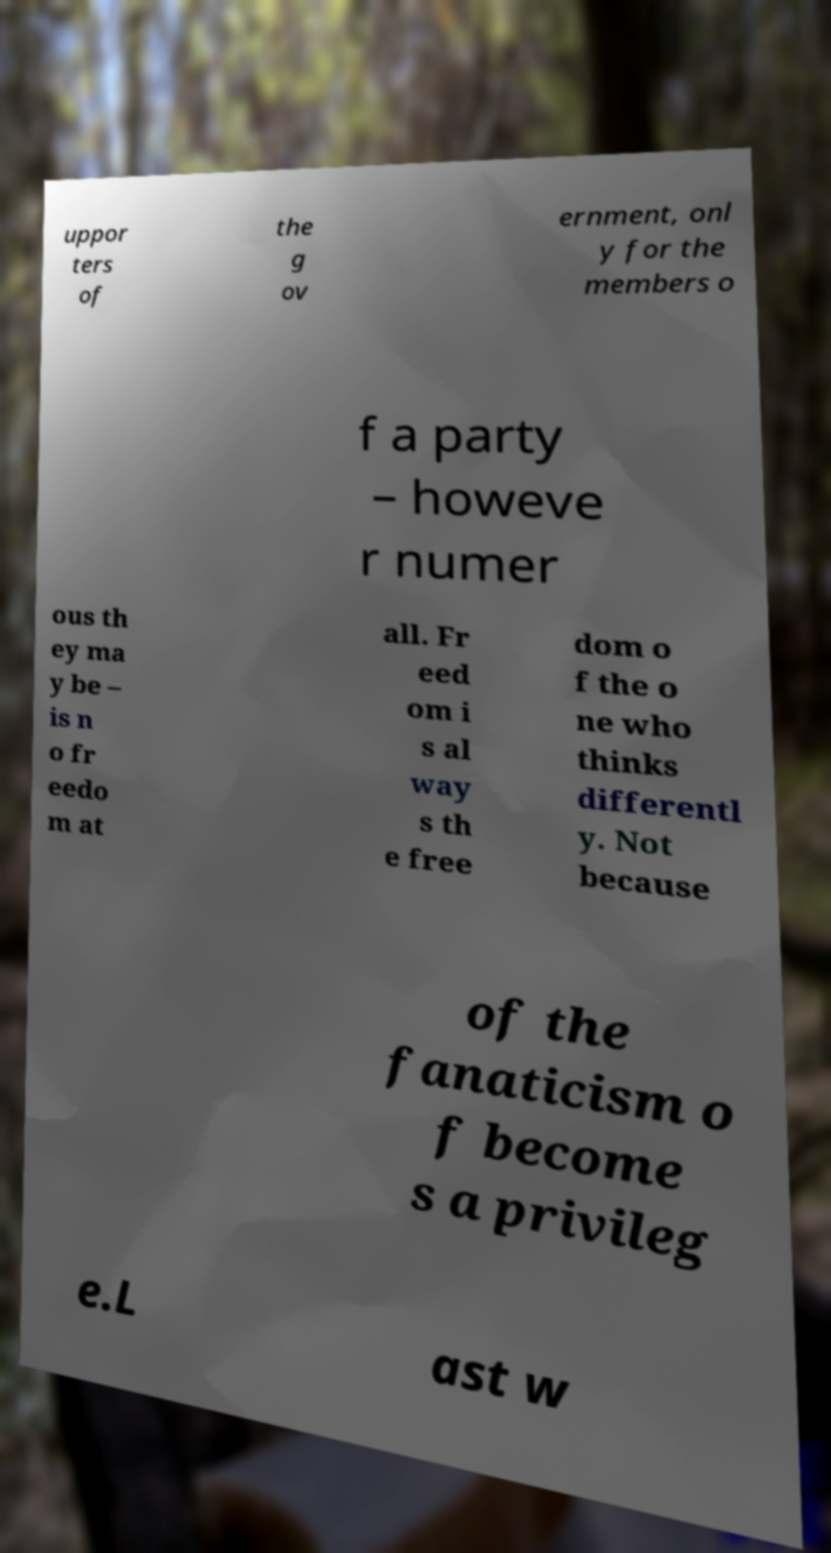I need the written content from this picture converted into text. Can you do that? uppor ters of the g ov ernment, onl y for the members o f a party – howeve r numer ous th ey ma y be – is n o fr eedo m at all. Fr eed om i s al way s th e free dom o f the o ne who thinks differentl y. Not because of the fanaticism o f become s a privileg e.L ast w 